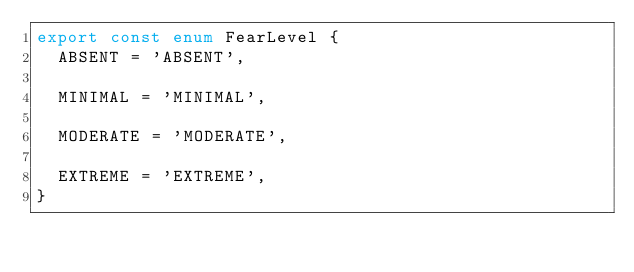<code> <loc_0><loc_0><loc_500><loc_500><_TypeScript_>export const enum FearLevel {
  ABSENT = 'ABSENT',

  MINIMAL = 'MINIMAL',

  MODERATE = 'MODERATE',

  EXTREME = 'EXTREME',
}
</code> 